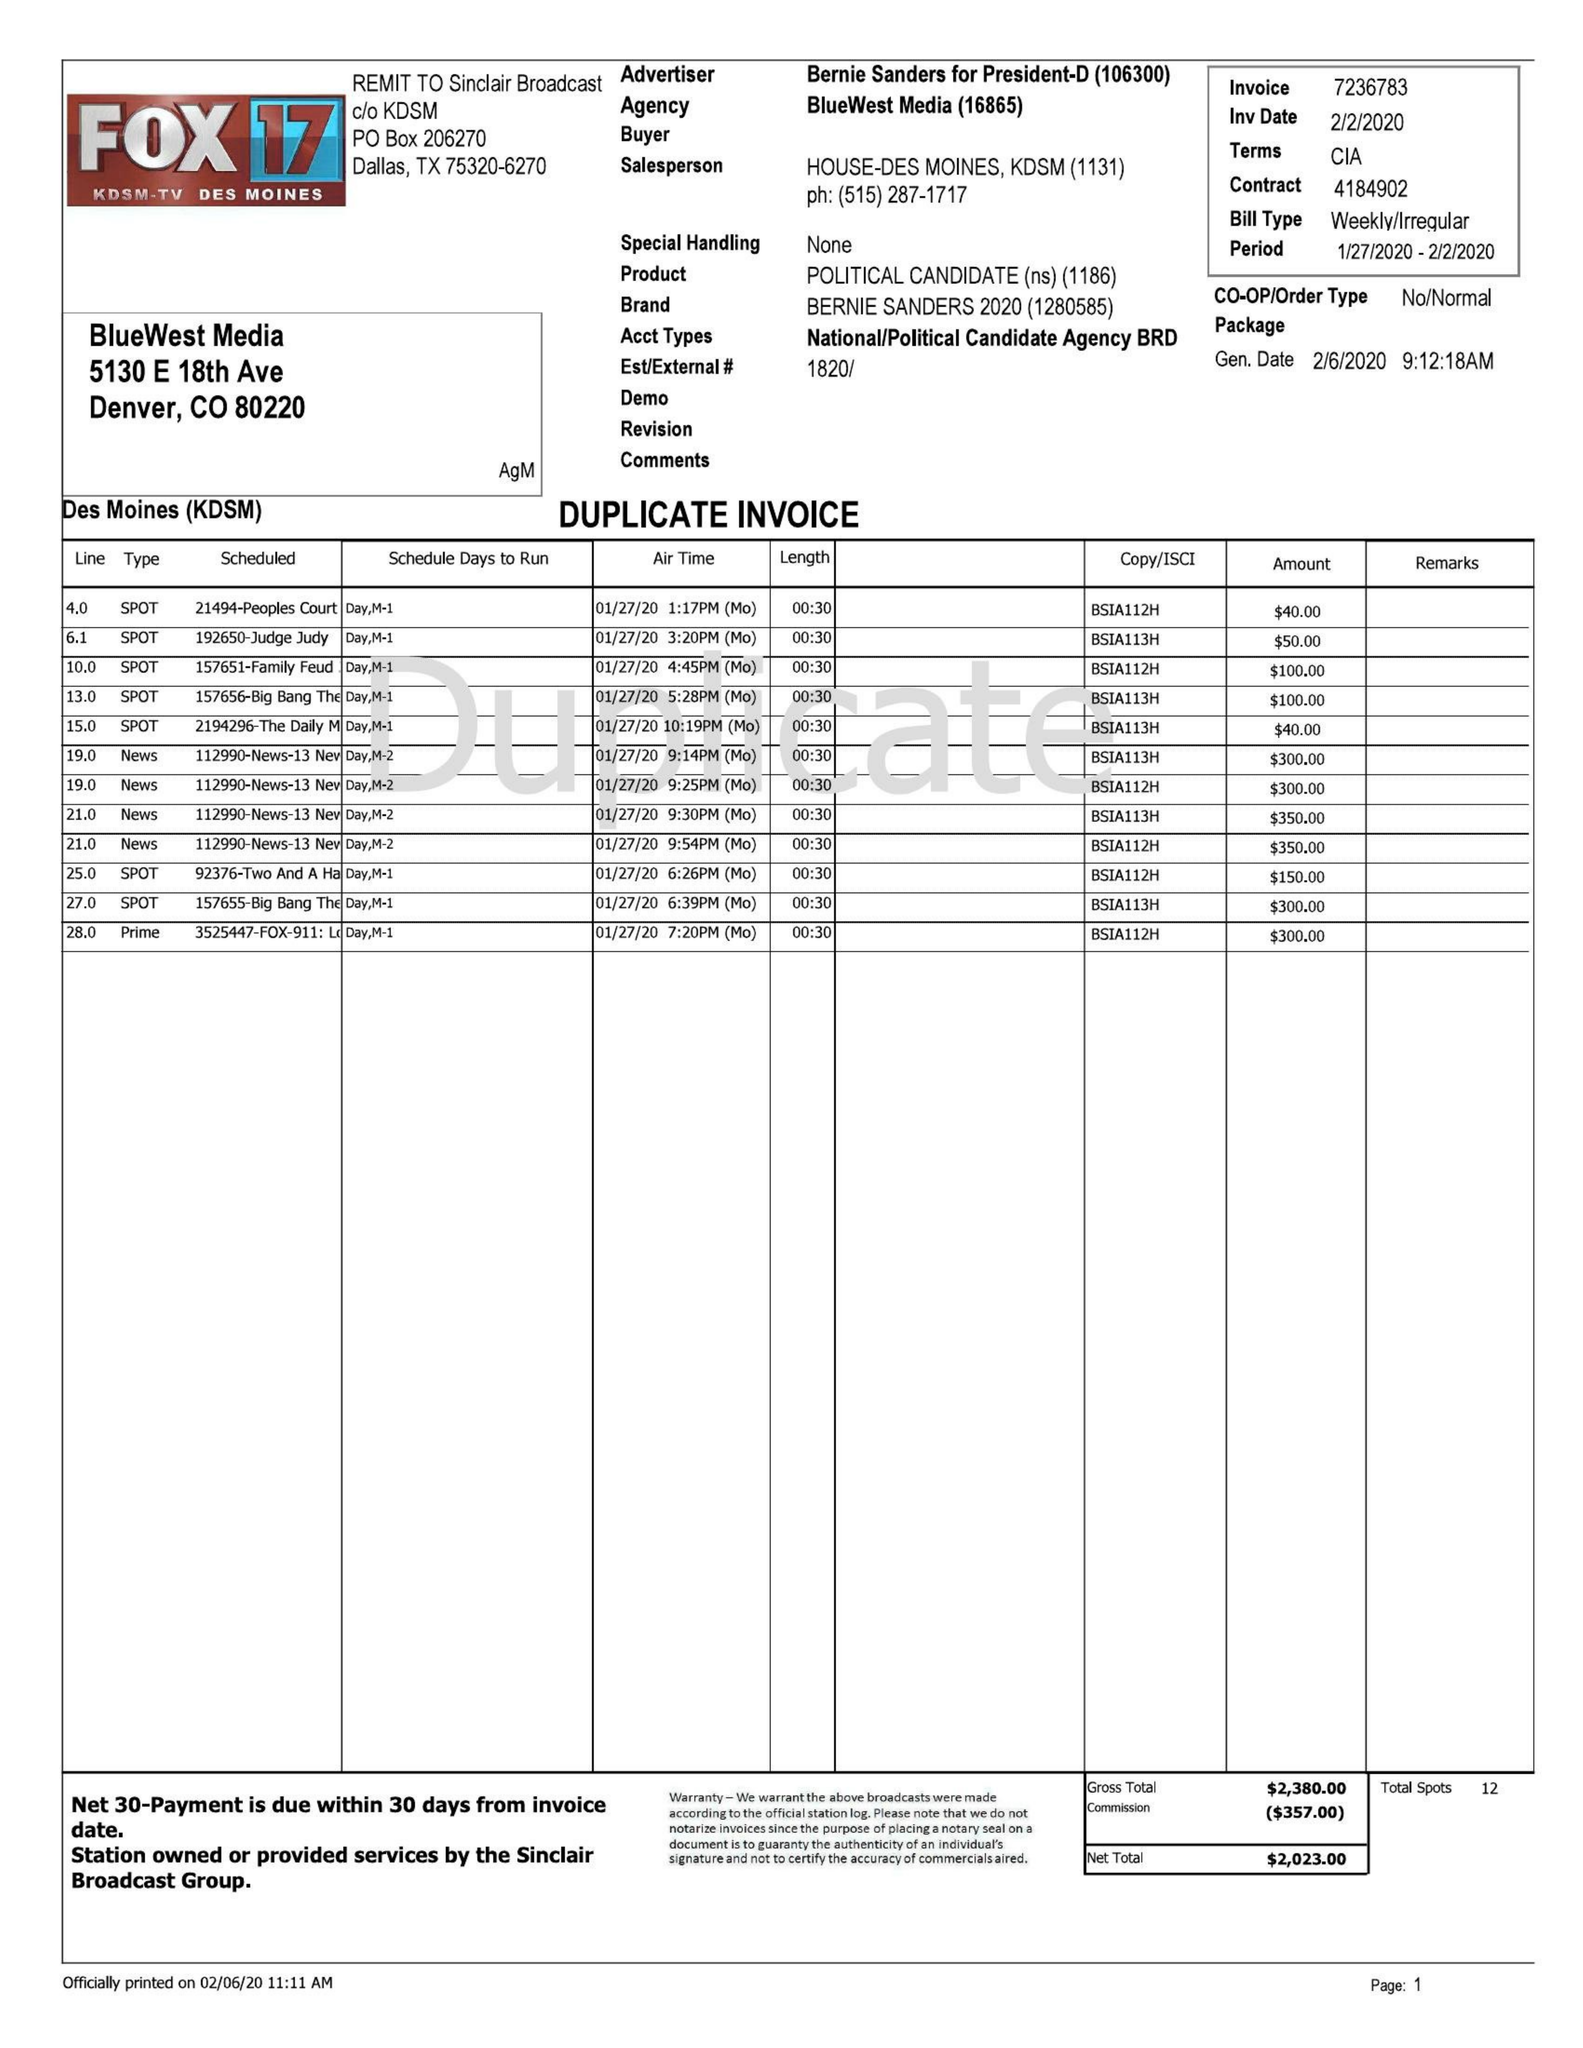What is the value for the advertiser?
Answer the question using a single word or phrase. BERNIE SANDERS FOR PRESIDENT-D 